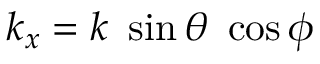<formula> <loc_0><loc_0><loc_500><loc_500>k _ { x } = k \sin \theta \cos \phi</formula> 